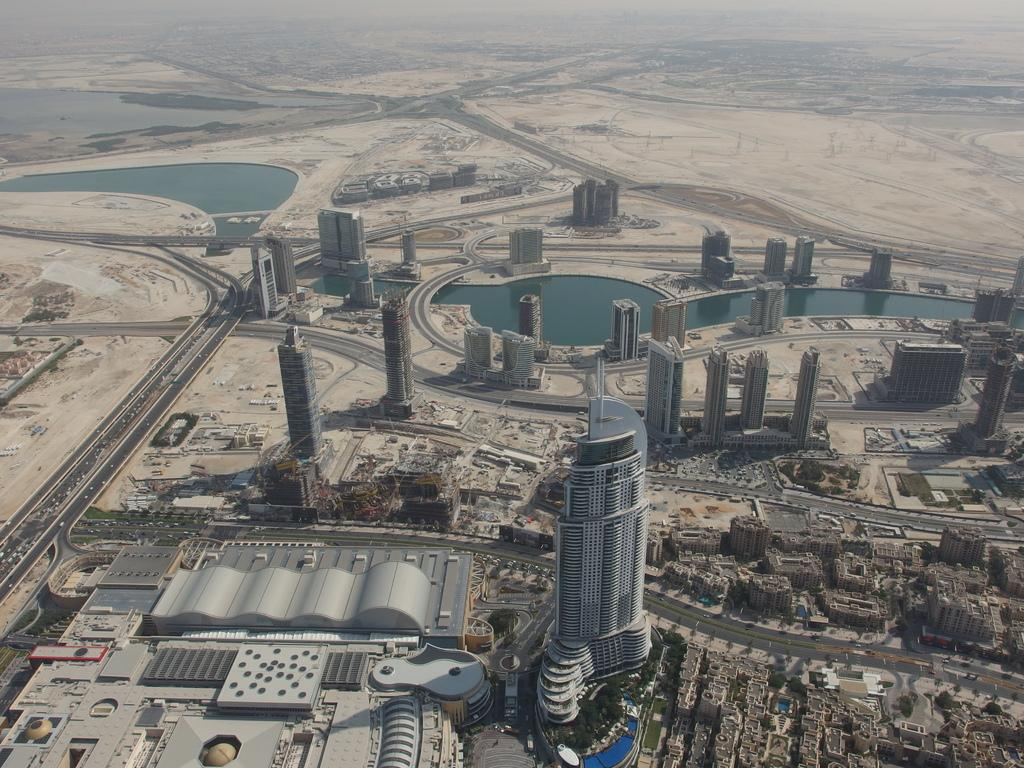What type of view is shown in the image? The image is an aerial view of a city. What structures can be seen in the image? There are buildings in the image. What type of transportation infrastructure is visible in the image? There are roads in the image. What natural feature can be seen in the image? There is water visible in the image. What type of landscape is visible in the image? There is a desert visible in the image. Where is the camera located in the image? There is no camera visible in the image; it is a photograph taken from an aerial perspective. What type of cup can be seen in the image? There is no cup present in the image. 